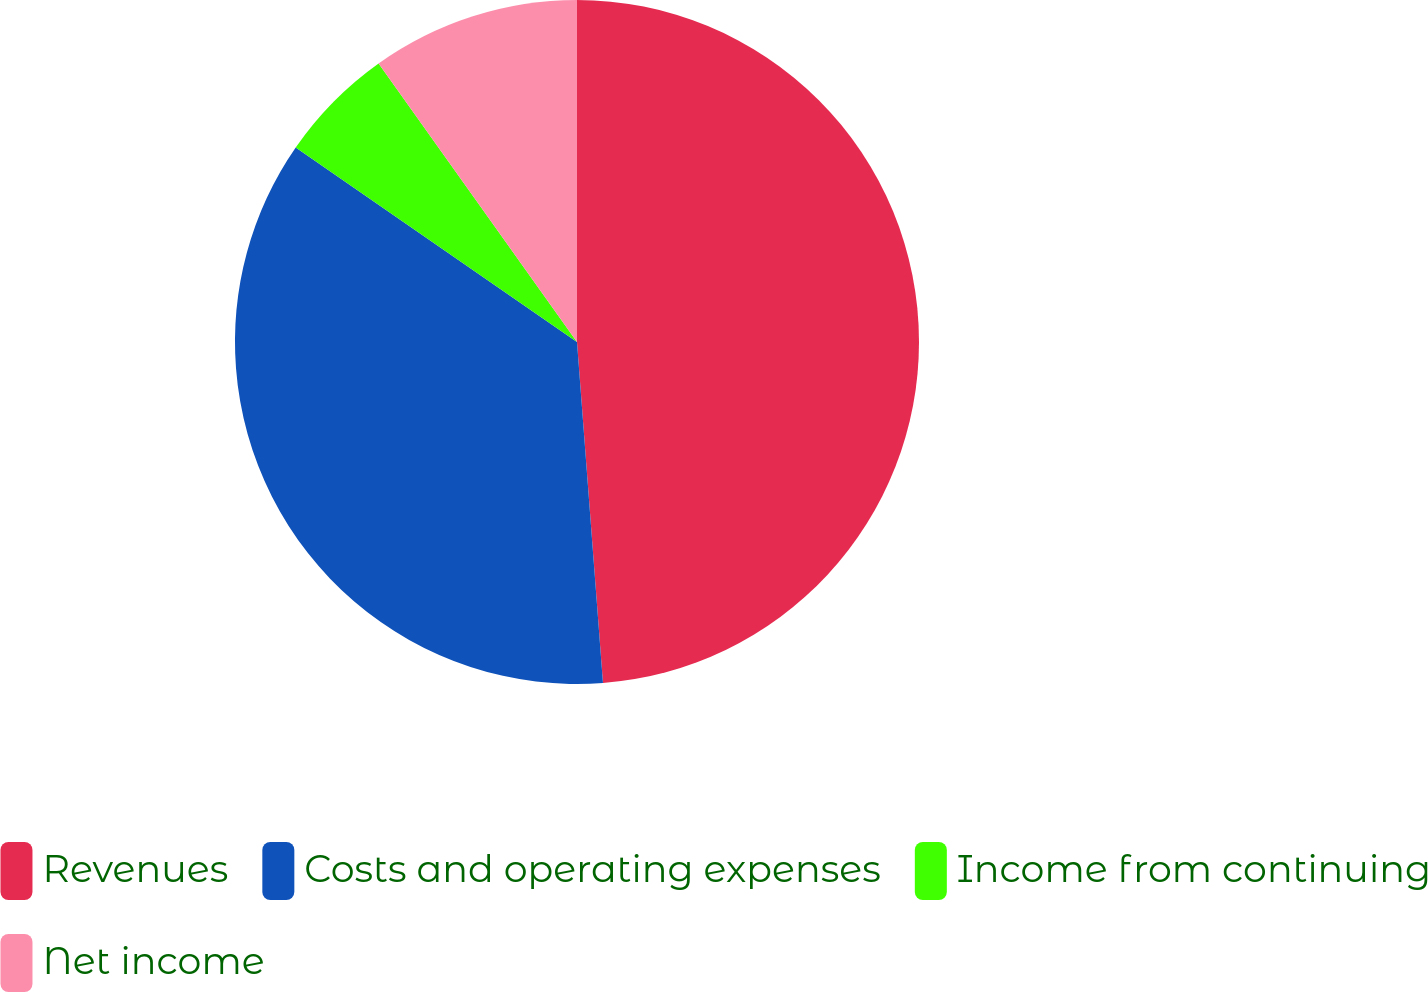<chart> <loc_0><loc_0><loc_500><loc_500><pie_chart><fcel>Revenues<fcel>Costs and operating expenses<fcel>Income from continuing<fcel>Net income<nl><fcel>48.79%<fcel>35.84%<fcel>5.52%<fcel>9.85%<nl></chart> 